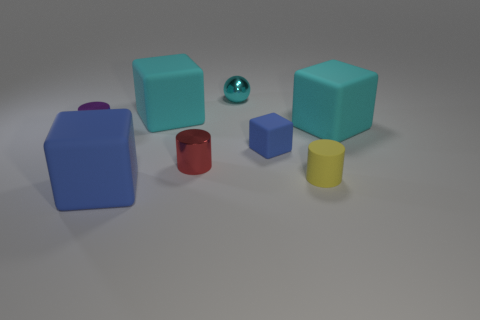Subtract all red cylinders. How many cylinders are left? 2 Subtract all purple cylinders. How many cylinders are left? 2 Subtract 3 cylinders. How many cylinders are left? 0 Add 2 brown rubber cylinders. How many objects exist? 10 Subtract all cyan blocks. Subtract all cyan spheres. How many blocks are left? 2 Subtract all balls. How many objects are left? 7 Subtract all gray spheres. How many brown blocks are left? 0 Subtract all small cyan metallic balls. Subtract all large blue blocks. How many objects are left? 6 Add 7 yellow rubber cylinders. How many yellow rubber cylinders are left? 8 Add 2 purple shiny cylinders. How many purple shiny cylinders exist? 3 